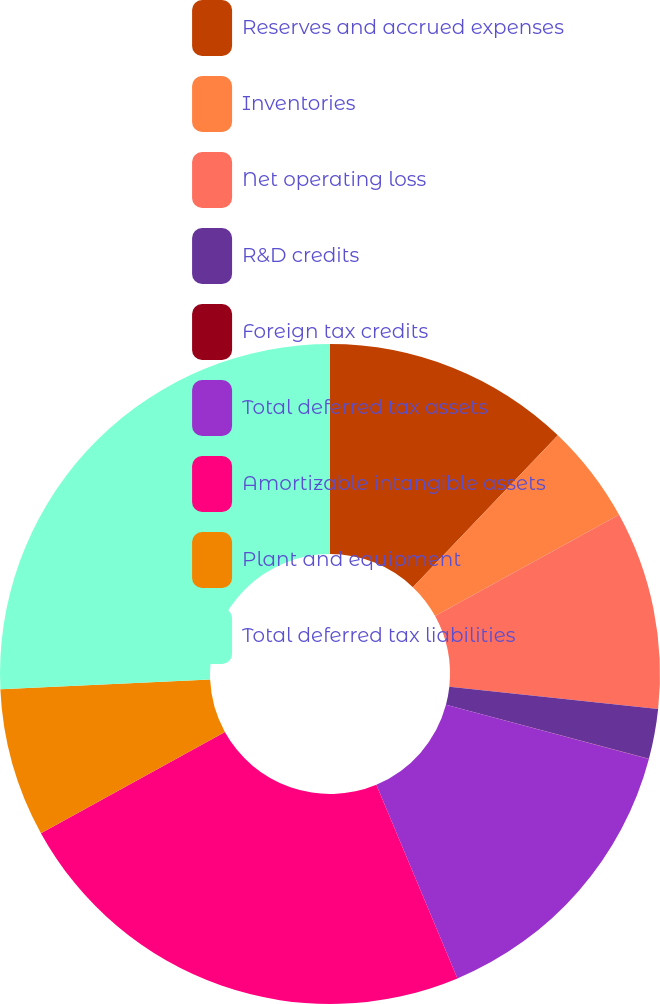Convert chart to OTSL. <chart><loc_0><loc_0><loc_500><loc_500><pie_chart><fcel>Reserves and accrued expenses<fcel>Inventories<fcel>Net operating loss<fcel>R&D credits<fcel>Foreign tax credits<fcel>Total deferred tax assets<fcel>Amortizable intangible assets<fcel>Plant and equipment<fcel>Total deferred tax liabilities<nl><fcel>12.13%<fcel>4.86%<fcel>9.7%<fcel>2.44%<fcel>0.01%<fcel>14.55%<fcel>23.3%<fcel>7.28%<fcel>25.73%<nl></chart> 